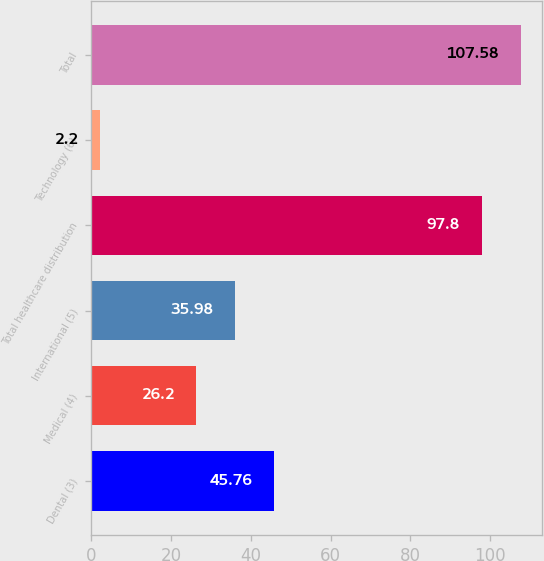<chart> <loc_0><loc_0><loc_500><loc_500><bar_chart><fcel>Dental (3)<fcel>Medical (4)<fcel>International (5)<fcel>Total healthcare distribution<fcel>Technology (6)<fcel>Total<nl><fcel>45.76<fcel>26.2<fcel>35.98<fcel>97.8<fcel>2.2<fcel>107.58<nl></chart> 